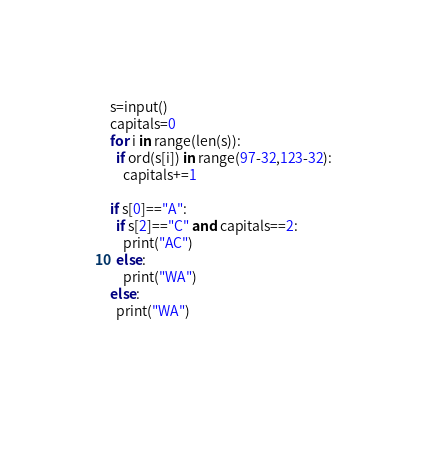Convert code to text. <code><loc_0><loc_0><loc_500><loc_500><_Python_>s=input()
capitals=0
for i in range(len(s)):
  if ord(s[i]) in range(97-32,123-32):
    capitals+=1
    
if s[0]=="A":
  if s[2]=="C" and capitals==2:
    print("AC")
  else:
    print("WA")
else:
  print("WA")
    
    
    </code> 